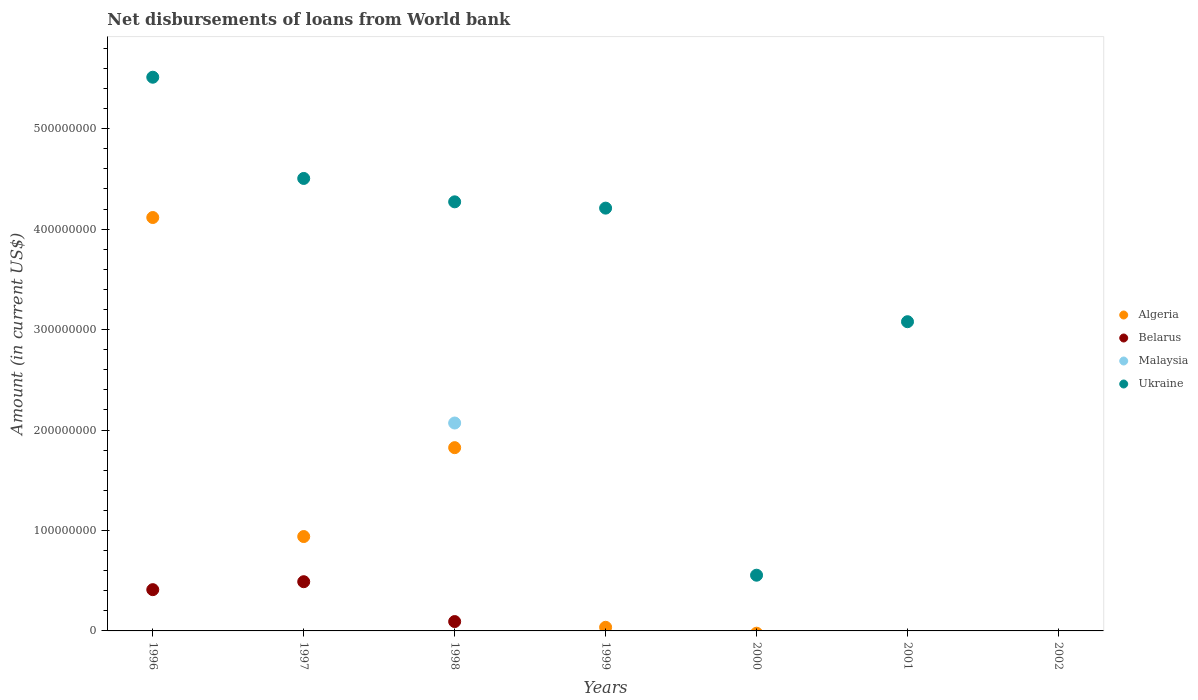How many different coloured dotlines are there?
Offer a very short reply. 4. Is the number of dotlines equal to the number of legend labels?
Ensure brevity in your answer.  No. Across all years, what is the maximum amount of loan disbursed from World Bank in Algeria?
Provide a succinct answer. 4.12e+08. Across all years, what is the minimum amount of loan disbursed from World Bank in Malaysia?
Offer a very short reply. 0. What is the total amount of loan disbursed from World Bank in Malaysia in the graph?
Your response must be concise. 2.07e+08. What is the difference between the amount of loan disbursed from World Bank in Ukraine in 1998 and that in 2001?
Ensure brevity in your answer.  1.19e+08. What is the difference between the amount of loan disbursed from World Bank in Ukraine in 2001 and the amount of loan disbursed from World Bank in Malaysia in 1996?
Provide a succinct answer. 3.08e+08. What is the average amount of loan disbursed from World Bank in Algeria per year?
Make the answer very short. 9.88e+07. In the year 1998, what is the difference between the amount of loan disbursed from World Bank in Ukraine and amount of loan disbursed from World Bank in Algeria?
Make the answer very short. 2.45e+08. Is the difference between the amount of loan disbursed from World Bank in Ukraine in 1996 and 1997 greater than the difference between the amount of loan disbursed from World Bank in Algeria in 1996 and 1997?
Your response must be concise. No. What is the difference between the highest and the second highest amount of loan disbursed from World Bank in Ukraine?
Your answer should be compact. 1.01e+08. What is the difference between the highest and the lowest amount of loan disbursed from World Bank in Belarus?
Your answer should be very brief. 4.90e+07. Is the sum of the amount of loan disbursed from World Bank in Ukraine in 1997 and 1999 greater than the maximum amount of loan disbursed from World Bank in Malaysia across all years?
Keep it short and to the point. Yes. Is it the case that in every year, the sum of the amount of loan disbursed from World Bank in Malaysia and amount of loan disbursed from World Bank in Belarus  is greater than the amount of loan disbursed from World Bank in Algeria?
Your answer should be compact. No. Does the amount of loan disbursed from World Bank in Malaysia monotonically increase over the years?
Offer a terse response. No. Is the amount of loan disbursed from World Bank in Algeria strictly greater than the amount of loan disbursed from World Bank in Malaysia over the years?
Make the answer very short. No. Is the amount of loan disbursed from World Bank in Algeria strictly less than the amount of loan disbursed from World Bank in Belarus over the years?
Provide a succinct answer. No. How many years are there in the graph?
Your response must be concise. 7. What is the difference between two consecutive major ticks on the Y-axis?
Your answer should be compact. 1.00e+08. Are the values on the major ticks of Y-axis written in scientific E-notation?
Provide a succinct answer. No. Does the graph contain any zero values?
Ensure brevity in your answer.  Yes. Where does the legend appear in the graph?
Your answer should be compact. Center right. How many legend labels are there?
Offer a terse response. 4. What is the title of the graph?
Your response must be concise. Net disbursements of loans from World bank. What is the label or title of the Y-axis?
Your response must be concise. Amount (in current US$). What is the Amount (in current US$) in Algeria in 1996?
Give a very brief answer. 4.12e+08. What is the Amount (in current US$) of Belarus in 1996?
Provide a succinct answer. 4.11e+07. What is the Amount (in current US$) in Malaysia in 1996?
Give a very brief answer. 0. What is the Amount (in current US$) of Ukraine in 1996?
Offer a very short reply. 5.51e+08. What is the Amount (in current US$) of Algeria in 1997?
Provide a short and direct response. 9.40e+07. What is the Amount (in current US$) of Belarus in 1997?
Keep it short and to the point. 4.90e+07. What is the Amount (in current US$) in Ukraine in 1997?
Your response must be concise. 4.50e+08. What is the Amount (in current US$) of Algeria in 1998?
Provide a short and direct response. 1.82e+08. What is the Amount (in current US$) in Belarus in 1998?
Your response must be concise. 9.31e+06. What is the Amount (in current US$) of Malaysia in 1998?
Keep it short and to the point. 2.07e+08. What is the Amount (in current US$) in Ukraine in 1998?
Provide a succinct answer. 4.27e+08. What is the Amount (in current US$) of Algeria in 1999?
Make the answer very short. 3.60e+06. What is the Amount (in current US$) in Ukraine in 1999?
Ensure brevity in your answer.  4.21e+08. What is the Amount (in current US$) in Algeria in 2000?
Make the answer very short. 0. What is the Amount (in current US$) of Belarus in 2000?
Provide a short and direct response. 0. What is the Amount (in current US$) of Malaysia in 2000?
Make the answer very short. 0. What is the Amount (in current US$) in Ukraine in 2000?
Offer a terse response. 5.55e+07. What is the Amount (in current US$) of Belarus in 2001?
Ensure brevity in your answer.  0. What is the Amount (in current US$) in Malaysia in 2001?
Provide a short and direct response. 0. What is the Amount (in current US$) of Ukraine in 2001?
Keep it short and to the point. 3.08e+08. What is the Amount (in current US$) of Algeria in 2002?
Your answer should be compact. 0. What is the Amount (in current US$) of Belarus in 2002?
Offer a very short reply. 0. What is the Amount (in current US$) in Malaysia in 2002?
Provide a succinct answer. 0. Across all years, what is the maximum Amount (in current US$) in Algeria?
Provide a short and direct response. 4.12e+08. Across all years, what is the maximum Amount (in current US$) in Belarus?
Keep it short and to the point. 4.90e+07. Across all years, what is the maximum Amount (in current US$) of Malaysia?
Offer a terse response. 2.07e+08. Across all years, what is the maximum Amount (in current US$) of Ukraine?
Provide a succinct answer. 5.51e+08. Across all years, what is the minimum Amount (in current US$) of Algeria?
Ensure brevity in your answer.  0. Across all years, what is the minimum Amount (in current US$) of Belarus?
Provide a short and direct response. 0. What is the total Amount (in current US$) in Algeria in the graph?
Make the answer very short. 6.92e+08. What is the total Amount (in current US$) of Belarus in the graph?
Give a very brief answer. 9.94e+07. What is the total Amount (in current US$) of Malaysia in the graph?
Your answer should be compact. 2.07e+08. What is the total Amount (in current US$) of Ukraine in the graph?
Your response must be concise. 2.21e+09. What is the difference between the Amount (in current US$) in Algeria in 1996 and that in 1997?
Your answer should be very brief. 3.18e+08. What is the difference between the Amount (in current US$) in Belarus in 1996 and that in 1997?
Make the answer very short. -7.91e+06. What is the difference between the Amount (in current US$) in Ukraine in 1996 and that in 1997?
Offer a terse response. 1.01e+08. What is the difference between the Amount (in current US$) of Algeria in 1996 and that in 1998?
Your answer should be very brief. 2.29e+08. What is the difference between the Amount (in current US$) in Belarus in 1996 and that in 1998?
Offer a terse response. 3.18e+07. What is the difference between the Amount (in current US$) of Ukraine in 1996 and that in 1998?
Offer a terse response. 1.24e+08. What is the difference between the Amount (in current US$) of Algeria in 1996 and that in 1999?
Offer a very short reply. 4.08e+08. What is the difference between the Amount (in current US$) of Ukraine in 1996 and that in 1999?
Keep it short and to the point. 1.30e+08. What is the difference between the Amount (in current US$) in Ukraine in 1996 and that in 2000?
Offer a terse response. 4.96e+08. What is the difference between the Amount (in current US$) of Ukraine in 1996 and that in 2001?
Offer a terse response. 2.43e+08. What is the difference between the Amount (in current US$) of Algeria in 1997 and that in 1998?
Provide a short and direct response. -8.85e+07. What is the difference between the Amount (in current US$) in Belarus in 1997 and that in 1998?
Provide a short and direct response. 3.97e+07. What is the difference between the Amount (in current US$) of Ukraine in 1997 and that in 1998?
Your response must be concise. 2.33e+07. What is the difference between the Amount (in current US$) in Algeria in 1997 and that in 1999?
Provide a short and direct response. 9.04e+07. What is the difference between the Amount (in current US$) of Ukraine in 1997 and that in 1999?
Your response must be concise. 2.96e+07. What is the difference between the Amount (in current US$) in Ukraine in 1997 and that in 2000?
Ensure brevity in your answer.  3.95e+08. What is the difference between the Amount (in current US$) of Ukraine in 1997 and that in 2001?
Provide a short and direct response. 1.43e+08. What is the difference between the Amount (in current US$) in Algeria in 1998 and that in 1999?
Offer a terse response. 1.79e+08. What is the difference between the Amount (in current US$) in Ukraine in 1998 and that in 1999?
Your answer should be very brief. 6.27e+06. What is the difference between the Amount (in current US$) of Ukraine in 1998 and that in 2000?
Provide a short and direct response. 3.72e+08. What is the difference between the Amount (in current US$) in Ukraine in 1998 and that in 2001?
Ensure brevity in your answer.  1.19e+08. What is the difference between the Amount (in current US$) in Ukraine in 1999 and that in 2000?
Ensure brevity in your answer.  3.65e+08. What is the difference between the Amount (in current US$) in Ukraine in 1999 and that in 2001?
Your answer should be very brief. 1.13e+08. What is the difference between the Amount (in current US$) of Ukraine in 2000 and that in 2001?
Ensure brevity in your answer.  -2.52e+08. What is the difference between the Amount (in current US$) of Algeria in 1996 and the Amount (in current US$) of Belarus in 1997?
Your response must be concise. 3.63e+08. What is the difference between the Amount (in current US$) of Algeria in 1996 and the Amount (in current US$) of Ukraine in 1997?
Ensure brevity in your answer.  -3.89e+07. What is the difference between the Amount (in current US$) of Belarus in 1996 and the Amount (in current US$) of Ukraine in 1997?
Give a very brief answer. -4.09e+08. What is the difference between the Amount (in current US$) in Algeria in 1996 and the Amount (in current US$) in Belarus in 1998?
Ensure brevity in your answer.  4.02e+08. What is the difference between the Amount (in current US$) of Algeria in 1996 and the Amount (in current US$) of Malaysia in 1998?
Offer a very short reply. 2.05e+08. What is the difference between the Amount (in current US$) in Algeria in 1996 and the Amount (in current US$) in Ukraine in 1998?
Offer a very short reply. -1.56e+07. What is the difference between the Amount (in current US$) in Belarus in 1996 and the Amount (in current US$) in Malaysia in 1998?
Give a very brief answer. -1.66e+08. What is the difference between the Amount (in current US$) of Belarus in 1996 and the Amount (in current US$) of Ukraine in 1998?
Your answer should be compact. -3.86e+08. What is the difference between the Amount (in current US$) in Algeria in 1996 and the Amount (in current US$) in Ukraine in 1999?
Your answer should be compact. -9.34e+06. What is the difference between the Amount (in current US$) in Belarus in 1996 and the Amount (in current US$) in Ukraine in 1999?
Provide a succinct answer. -3.80e+08. What is the difference between the Amount (in current US$) of Algeria in 1996 and the Amount (in current US$) of Ukraine in 2000?
Your response must be concise. 3.56e+08. What is the difference between the Amount (in current US$) in Belarus in 1996 and the Amount (in current US$) in Ukraine in 2000?
Offer a very short reply. -1.44e+07. What is the difference between the Amount (in current US$) in Algeria in 1996 and the Amount (in current US$) in Ukraine in 2001?
Offer a terse response. 1.04e+08. What is the difference between the Amount (in current US$) in Belarus in 1996 and the Amount (in current US$) in Ukraine in 2001?
Your answer should be compact. -2.67e+08. What is the difference between the Amount (in current US$) in Algeria in 1997 and the Amount (in current US$) in Belarus in 1998?
Ensure brevity in your answer.  8.46e+07. What is the difference between the Amount (in current US$) in Algeria in 1997 and the Amount (in current US$) in Malaysia in 1998?
Keep it short and to the point. -1.13e+08. What is the difference between the Amount (in current US$) of Algeria in 1997 and the Amount (in current US$) of Ukraine in 1998?
Provide a succinct answer. -3.33e+08. What is the difference between the Amount (in current US$) in Belarus in 1997 and the Amount (in current US$) in Malaysia in 1998?
Keep it short and to the point. -1.58e+08. What is the difference between the Amount (in current US$) in Belarus in 1997 and the Amount (in current US$) in Ukraine in 1998?
Provide a short and direct response. -3.78e+08. What is the difference between the Amount (in current US$) of Algeria in 1997 and the Amount (in current US$) of Ukraine in 1999?
Ensure brevity in your answer.  -3.27e+08. What is the difference between the Amount (in current US$) in Belarus in 1997 and the Amount (in current US$) in Ukraine in 1999?
Your response must be concise. -3.72e+08. What is the difference between the Amount (in current US$) in Algeria in 1997 and the Amount (in current US$) in Ukraine in 2000?
Your response must be concise. 3.85e+07. What is the difference between the Amount (in current US$) in Belarus in 1997 and the Amount (in current US$) in Ukraine in 2000?
Your answer should be compact. -6.48e+06. What is the difference between the Amount (in current US$) of Algeria in 1997 and the Amount (in current US$) of Ukraine in 2001?
Ensure brevity in your answer.  -2.14e+08. What is the difference between the Amount (in current US$) in Belarus in 1997 and the Amount (in current US$) in Ukraine in 2001?
Make the answer very short. -2.59e+08. What is the difference between the Amount (in current US$) of Algeria in 1998 and the Amount (in current US$) of Ukraine in 1999?
Make the answer very short. -2.38e+08. What is the difference between the Amount (in current US$) in Belarus in 1998 and the Amount (in current US$) in Ukraine in 1999?
Provide a short and direct response. -4.12e+08. What is the difference between the Amount (in current US$) in Malaysia in 1998 and the Amount (in current US$) in Ukraine in 1999?
Ensure brevity in your answer.  -2.14e+08. What is the difference between the Amount (in current US$) of Algeria in 1998 and the Amount (in current US$) of Ukraine in 2000?
Keep it short and to the point. 1.27e+08. What is the difference between the Amount (in current US$) in Belarus in 1998 and the Amount (in current US$) in Ukraine in 2000?
Offer a terse response. -4.62e+07. What is the difference between the Amount (in current US$) in Malaysia in 1998 and the Amount (in current US$) in Ukraine in 2000?
Your response must be concise. 1.52e+08. What is the difference between the Amount (in current US$) of Algeria in 1998 and the Amount (in current US$) of Ukraine in 2001?
Give a very brief answer. -1.25e+08. What is the difference between the Amount (in current US$) of Belarus in 1998 and the Amount (in current US$) of Ukraine in 2001?
Your response must be concise. -2.99e+08. What is the difference between the Amount (in current US$) in Malaysia in 1998 and the Amount (in current US$) in Ukraine in 2001?
Ensure brevity in your answer.  -1.01e+08. What is the difference between the Amount (in current US$) in Algeria in 1999 and the Amount (in current US$) in Ukraine in 2000?
Keep it short and to the point. -5.19e+07. What is the difference between the Amount (in current US$) of Algeria in 1999 and the Amount (in current US$) of Ukraine in 2001?
Offer a very short reply. -3.04e+08. What is the average Amount (in current US$) of Algeria per year?
Offer a terse response. 9.88e+07. What is the average Amount (in current US$) in Belarus per year?
Provide a succinct answer. 1.42e+07. What is the average Amount (in current US$) of Malaysia per year?
Give a very brief answer. 2.96e+07. What is the average Amount (in current US$) of Ukraine per year?
Make the answer very short. 3.16e+08. In the year 1996, what is the difference between the Amount (in current US$) of Algeria and Amount (in current US$) of Belarus?
Your answer should be compact. 3.70e+08. In the year 1996, what is the difference between the Amount (in current US$) in Algeria and Amount (in current US$) in Ukraine?
Ensure brevity in your answer.  -1.40e+08. In the year 1996, what is the difference between the Amount (in current US$) of Belarus and Amount (in current US$) of Ukraine?
Give a very brief answer. -5.10e+08. In the year 1997, what is the difference between the Amount (in current US$) of Algeria and Amount (in current US$) of Belarus?
Your response must be concise. 4.50e+07. In the year 1997, what is the difference between the Amount (in current US$) of Algeria and Amount (in current US$) of Ukraine?
Provide a succinct answer. -3.57e+08. In the year 1997, what is the difference between the Amount (in current US$) of Belarus and Amount (in current US$) of Ukraine?
Your answer should be compact. -4.01e+08. In the year 1998, what is the difference between the Amount (in current US$) of Algeria and Amount (in current US$) of Belarus?
Your response must be concise. 1.73e+08. In the year 1998, what is the difference between the Amount (in current US$) of Algeria and Amount (in current US$) of Malaysia?
Give a very brief answer. -2.45e+07. In the year 1998, what is the difference between the Amount (in current US$) in Algeria and Amount (in current US$) in Ukraine?
Offer a very short reply. -2.45e+08. In the year 1998, what is the difference between the Amount (in current US$) of Belarus and Amount (in current US$) of Malaysia?
Your answer should be compact. -1.98e+08. In the year 1998, what is the difference between the Amount (in current US$) in Belarus and Amount (in current US$) in Ukraine?
Provide a succinct answer. -4.18e+08. In the year 1998, what is the difference between the Amount (in current US$) of Malaysia and Amount (in current US$) of Ukraine?
Ensure brevity in your answer.  -2.20e+08. In the year 1999, what is the difference between the Amount (in current US$) of Algeria and Amount (in current US$) of Ukraine?
Keep it short and to the point. -4.17e+08. What is the ratio of the Amount (in current US$) of Algeria in 1996 to that in 1997?
Your answer should be compact. 4.38. What is the ratio of the Amount (in current US$) in Belarus in 1996 to that in 1997?
Your answer should be very brief. 0.84. What is the ratio of the Amount (in current US$) in Ukraine in 1996 to that in 1997?
Offer a terse response. 1.22. What is the ratio of the Amount (in current US$) of Algeria in 1996 to that in 1998?
Your answer should be compact. 2.26. What is the ratio of the Amount (in current US$) of Belarus in 1996 to that in 1998?
Your answer should be compact. 4.41. What is the ratio of the Amount (in current US$) of Ukraine in 1996 to that in 1998?
Give a very brief answer. 1.29. What is the ratio of the Amount (in current US$) in Algeria in 1996 to that in 1999?
Your answer should be very brief. 114.17. What is the ratio of the Amount (in current US$) of Ukraine in 1996 to that in 1999?
Your response must be concise. 1.31. What is the ratio of the Amount (in current US$) of Ukraine in 1996 to that in 2000?
Provide a short and direct response. 9.94. What is the ratio of the Amount (in current US$) in Ukraine in 1996 to that in 2001?
Offer a very short reply. 1.79. What is the ratio of the Amount (in current US$) of Algeria in 1997 to that in 1998?
Give a very brief answer. 0.52. What is the ratio of the Amount (in current US$) of Belarus in 1997 to that in 1998?
Your answer should be compact. 5.26. What is the ratio of the Amount (in current US$) of Ukraine in 1997 to that in 1998?
Ensure brevity in your answer.  1.05. What is the ratio of the Amount (in current US$) of Algeria in 1997 to that in 1999?
Your answer should be compact. 26.06. What is the ratio of the Amount (in current US$) in Ukraine in 1997 to that in 1999?
Your response must be concise. 1.07. What is the ratio of the Amount (in current US$) in Ukraine in 1997 to that in 2000?
Ensure brevity in your answer.  8.12. What is the ratio of the Amount (in current US$) of Ukraine in 1997 to that in 2001?
Provide a short and direct response. 1.46. What is the ratio of the Amount (in current US$) of Algeria in 1998 to that in 1999?
Offer a terse response. 50.61. What is the ratio of the Amount (in current US$) of Ukraine in 1998 to that in 1999?
Provide a short and direct response. 1.01. What is the ratio of the Amount (in current US$) in Ukraine in 1998 to that in 2000?
Your answer should be compact. 7.7. What is the ratio of the Amount (in current US$) in Ukraine in 1998 to that in 2001?
Your answer should be compact. 1.39. What is the ratio of the Amount (in current US$) of Ukraine in 1999 to that in 2000?
Keep it short and to the point. 7.59. What is the ratio of the Amount (in current US$) in Ukraine in 1999 to that in 2001?
Offer a very short reply. 1.37. What is the ratio of the Amount (in current US$) in Ukraine in 2000 to that in 2001?
Provide a short and direct response. 0.18. What is the difference between the highest and the second highest Amount (in current US$) of Algeria?
Ensure brevity in your answer.  2.29e+08. What is the difference between the highest and the second highest Amount (in current US$) in Belarus?
Make the answer very short. 7.91e+06. What is the difference between the highest and the second highest Amount (in current US$) in Ukraine?
Ensure brevity in your answer.  1.01e+08. What is the difference between the highest and the lowest Amount (in current US$) of Algeria?
Offer a very short reply. 4.12e+08. What is the difference between the highest and the lowest Amount (in current US$) of Belarus?
Ensure brevity in your answer.  4.90e+07. What is the difference between the highest and the lowest Amount (in current US$) in Malaysia?
Give a very brief answer. 2.07e+08. What is the difference between the highest and the lowest Amount (in current US$) in Ukraine?
Offer a very short reply. 5.51e+08. 